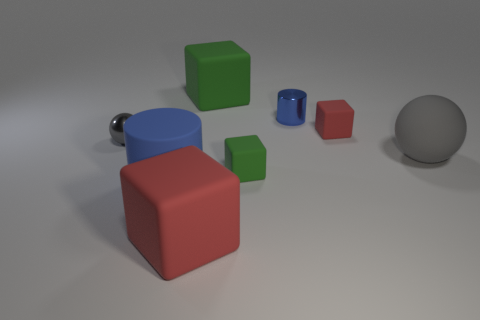What materials appear to be present in the objects displayed? The objects seem to be made of various materials. The green and red cubes may be of a plastic or matte material, while the blue cylinder and the sphere look metallic due to their reflective surface. The larger blue cube with a knob also seems metallic. 